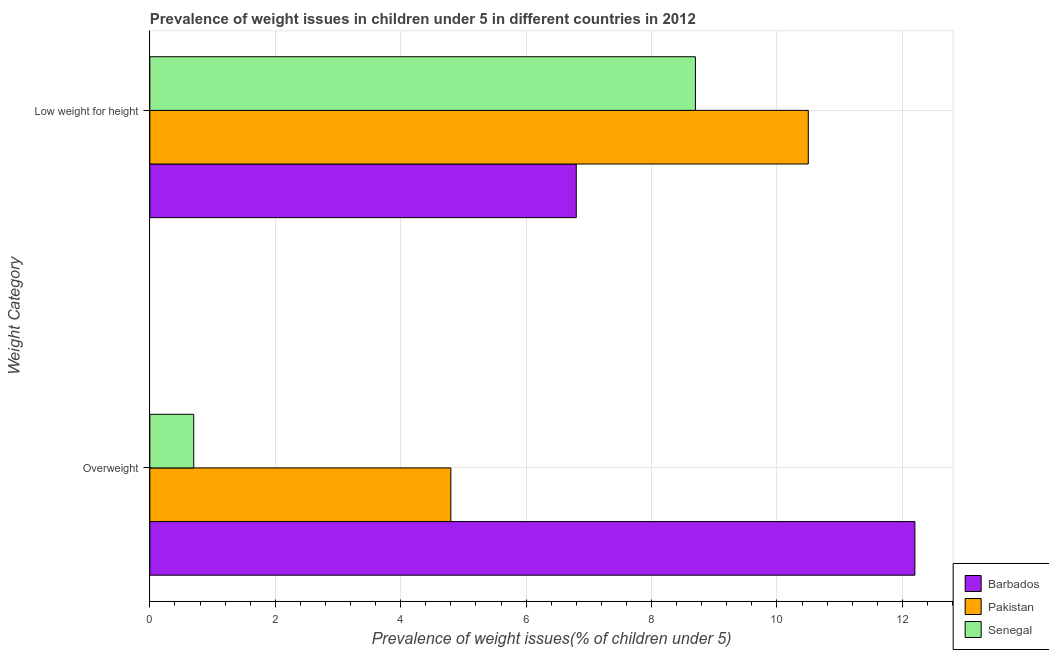How many different coloured bars are there?
Your answer should be very brief. 3. How many groups of bars are there?
Your response must be concise. 2. Are the number of bars per tick equal to the number of legend labels?
Offer a terse response. Yes. Are the number of bars on each tick of the Y-axis equal?
Provide a succinct answer. Yes. How many bars are there on the 2nd tick from the top?
Your answer should be compact. 3. What is the label of the 2nd group of bars from the top?
Make the answer very short. Overweight. What is the percentage of overweight children in Senegal?
Offer a very short reply. 0.7. Across all countries, what is the maximum percentage of overweight children?
Give a very brief answer. 12.2. Across all countries, what is the minimum percentage of underweight children?
Ensure brevity in your answer.  6.8. In which country was the percentage of overweight children maximum?
Offer a terse response. Barbados. In which country was the percentage of underweight children minimum?
Keep it short and to the point. Barbados. What is the total percentage of underweight children in the graph?
Keep it short and to the point. 26. What is the difference between the percentage of overweight children in Senegal and that in Pakistan?
Provide a succinct answer. -4.1. What is the difference between the percentage of overweight children in Senegal and the percentage of underweight children in Pakistan?
Your answer should be compact. -9.8. What is the average percentage of underweight children per country?
Ensure brevity in your answer.  8.67. What is the difference between the percentage of overweight children and percentage of underweight children in Pakistan?
Ensure brevity in your answer.  -5.7. What is the ratio of the percentage of underweight children in Senegal to that in Pakistan?
Ensure brevity in your answer.  0.83. In how many countries, is the percentage of overweight children greater than the average percentage of overweight children taken over all countries?
Make the answer very short. 1. What does the 3rd bar from the top in Overweight represents?
Provide a succinct answer. Barbados. What does the 3rd bar from the bottom in Overweight represents?
Ensure brevity in your answer.  Senegal. Are the values on the major ticks of X-axis written in scientific E-notation?
Keep it short and to the point. No. Does the graph contain any zero values?
Your answer should be very brief. No. Does the graph contain grids?
Your response must be concise. Yes. Where does the legend appear in the graph?
Provide a short and direct response. Bottom right. How many legend labels are there?
Ensure brevity in your answer.  3. How are the legend labels stacked?
Make the answer very short. Vertical. What is the title of the graph?
Keep it short and to the point. Prevalence of weight issues in children under 5 in different countries in 2012. What is the label or title of the X-axis?
Your answer should be very brief. Prevalence of weight issues(% of children under 5). What is the label or title of the Y-axis?
Your answer should be compact. Weight Category. What is the Prevalence of weight issues(% of children under 5) of Barbados in Overweight?
Offer a terse response. 12.2. What is the Prevalence of weight issues(% of children under 5) of Pakistan in Overweight?
Provide a short and direct response. 4.8. What is the Prevalence of weight issues(% of children under 5) of Senegal in Overweight?
Your response must be concise. 0.7. What is the Prevalence of weight issues(% of children under 5) of Barbados in Low weight for height?
Your answer should be very brief. 6.8. What is the Prevalence of weight issues(% of children under 5) in Senegal in Low weight for height?
Offer a terse response. 8.7. Across all Weight Category, what is the maximum Prevalence of weight issues(% of children under 5) of Barbados?
Ensure brevity in your answer.  12.2. Across all Weight Category, what is the maximum Prevalence of weight issues(% of children under 5) of Pakistan?
Offer a very short reply. 10.5. Across all Weight Category, what is the maximum Prevalence of weight issues(% of children under 5) of Senegal?
Keep it short and to the point. 8.7. Across all Weight Category, what is the minimum Prevalence of weight issues(% of children under 5) of Barbados?
Keep it short and to the point. 6.8. Across all Weight Category, what is the minimum Prevalence of weight issues(% of children under 5) of Pakistan?
Offer a very short reply. 4.8. Across all Weight Category, what is the minimum Prevalence of weight issues(% of children under 5) of Senegal?
Your response must be concise. 0.7. What is the total Prevalence of weight issues(% of children under 5) of Barbados in the graph?
Provide a succinct answer. 19. What is the total Prevalence of weight issues(% of children under 5) in Pakistan in the graph?
Provide a succinct answer. 15.3. What is the difference between the Prevalence of weight issues(% of children under 5) in Pakistan in Overweight and the Prevalence of weight issues(% of children under 5) in Senegal in Low weight for height?
Make the answer very short. -3.9. What is the average Prevalence of weight issues(% of children under 5) in Pakistan per Weight Category?
Give a very brief answer. 7.65. What is the average Prevalence of weight issues(% of children under 5) of Senegal per Weight Category?
Make the answer very short. 4.7. What is the difference between the Prevalence of weight issues(% of children under 5) in Pakistan and Prevalence of weight issues(% of children under 5) in Senegal in Overweight?
Make the answer very short. 4.1. What is the difference between the Prevalence of weight issues(% of children under 5) of Barbados and Prevalence of weight issues(% of children under 5) of Pakistan in Low weight for height?
Offer a very short reply. -3.7. What is the ratio of the Prevalence of weight issues(% of children under 5) in Barbados in Overweight to that in Low weight for height?
Provide a short and direct response. 1.79. What is the ratio of the Prevalence of weight issues(% of children under 5) in Pakistan in Overweight to that in Low weight for height?
Ensure brevity in your answer.  0.46. What is the ratio of the Prevalence of weight issues(% of children under 5) of Senegal in Overweight to that in Low weight for height?
Your response must be concise. 0.08. What is the difference between the highest and the second highest Prevalence of weight issues(% of children under 5) in Pakistan?
Your answer should be very brief. 5.7. What is the difference between the highest and the second highest Prevalence of weight issues(% of children under 5) of Senegal?
Ensure brevity in your answer.  8. What is the difference between the highest and the lowest Prevalence of weight issues(% of children under 5) in Senegal?
Provide a short and direct response. 8. 